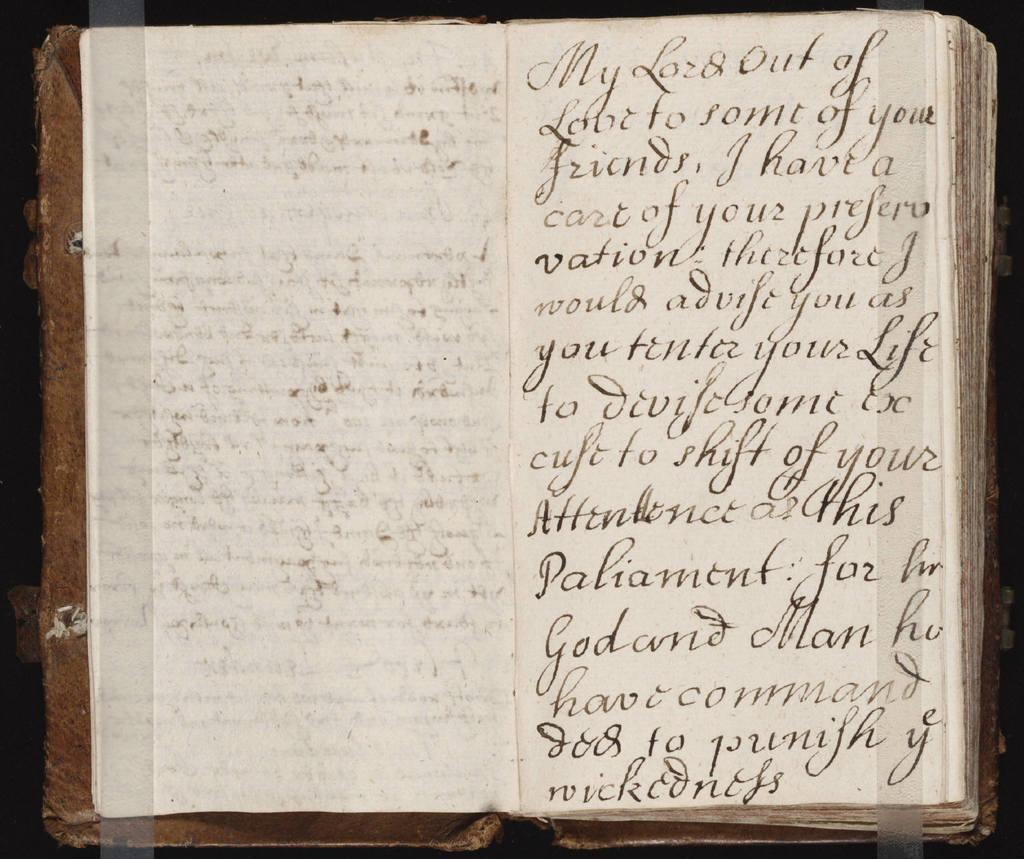Can you describe this image briefly? In this image I can see a book which is opened and there is some text. 